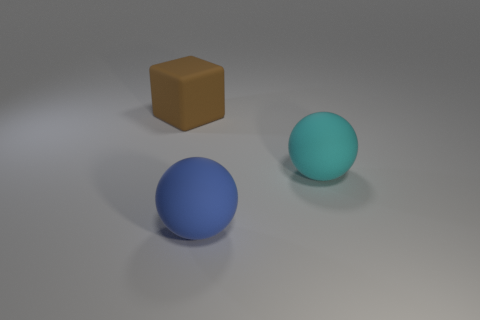Add 2 cyan objects. How many objects exist? 5 Subtract all blue balls. How many balls are left? 1 Subtract all blocks. How many objects are left? 2 Subtract 0 gray cylinders. How many objects are left? 3 Subtract 1 balls. How many balls are left? 1 Subtract all blue cubes. Subtract all purple spheres. How many cubes are left? 1 Subtract all cyan spheres. Subtract all large matte spheres. How many objects are left? 0 Add 1 blue matte balls. How many blue matte balls are left? 2 Add 2 tiny cylinders. How many tiny cylinders exist? 2 